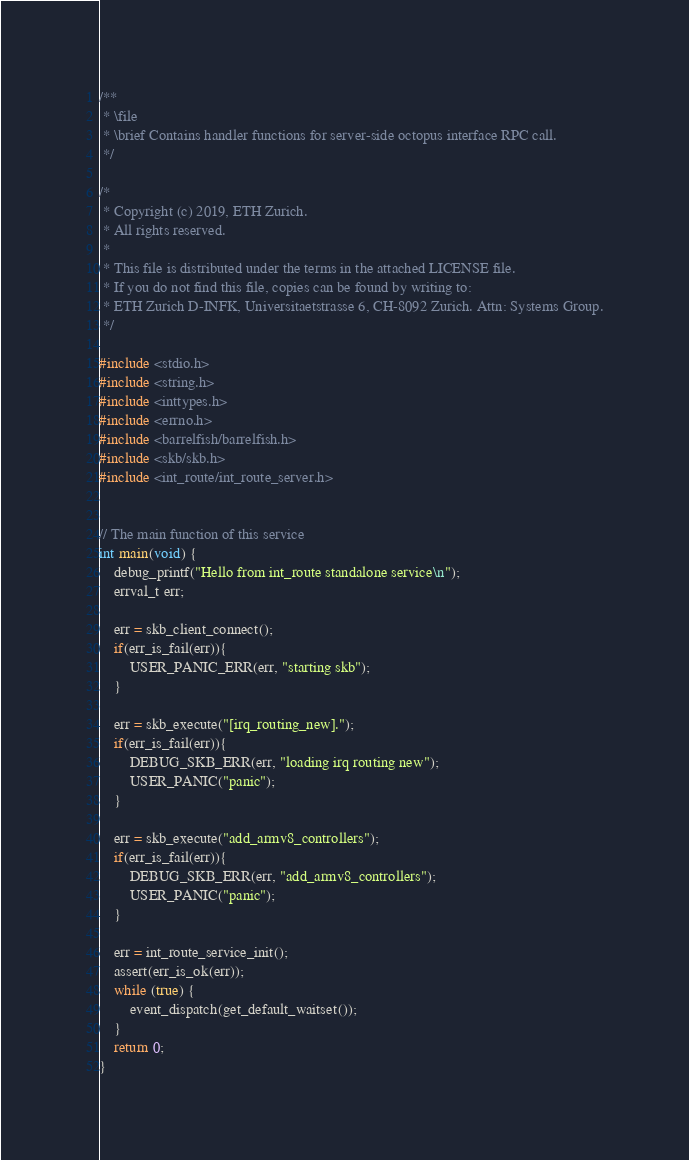Convert code to text. <code><loc_0><loc_0><loc_500><loc_500><_C_>/**
 * \file
 * \brief Contains handler functions for server-side octopus interface RPC call.
 */

/*
 * Copyright (c) 2019, ETH Zurich.
 * All rights reserved.
 *
 * This file is distributed under the terms in the attached LICENSE file.
 * If you do not find this file, copies can be found by writing to:
 * ETH Zurich D-INFK, Universitaetstrasse 6, CH-8092 Zurich. Attn: Systems Group.
 */

#include <stdio.h>
#include <string.h>
#include <inttypes.h>
#include <errno.h>
#include <barrelfish/barrelfish.h>
#include <skb/skb.h>
#include <int_route/int_route_server.h>


// The main function of this service
int main(void) {
    debug_printf("Hello from int_route standalone service\n");
    errval_t err;

    err = skb_client_connect();
    if(err_is_fail(err)){
        USER_PANIC_ERR(err, "starting skb");
    }

    err = skb_execute("[irq_routing_new].");
    if(err_is_fail(err)){
        DEBUG_SKB_ERR(err, "loading irq routing new");
        USER_PANIC("panic");
    }

    err = skb_execute("add_armv8_controllers");
    if(err_is_fail(err)){
        DEBUG_SKB_ERR(err, "add_armv8_controllers");
        USER_PANIC("panic");
    }

    err = int_route_service_init();
    assert(err_is_ok(err));
    while (true) {
        event_dispatch(get_default_waitset());
    }
    return 0;
}
</code> 